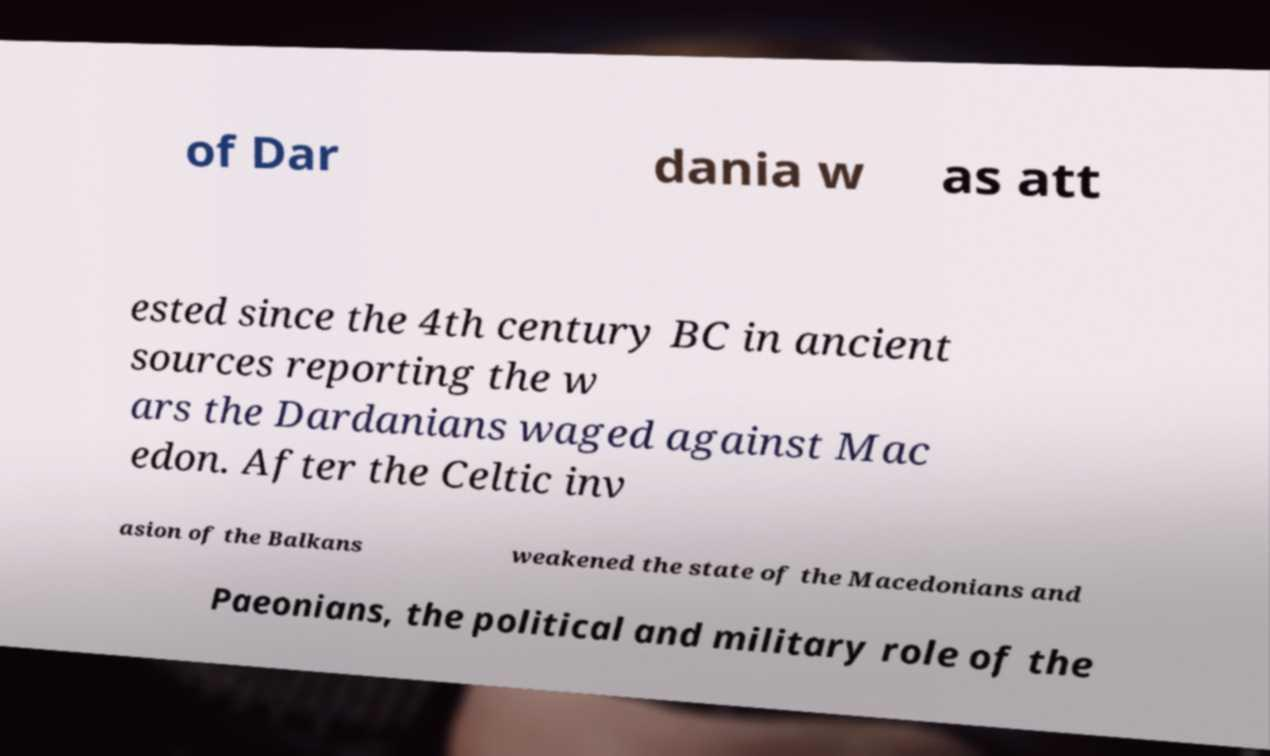Could you extract and type out the text from this image? of Dar dania w as att ested since the 4th century BC in ancient sources reporting the w ars the Dardanians waged against Mac edon. After the Celtic inv asion of the Balkans weakened the state of the Macedonians and Paeonians, the political and military role of the 